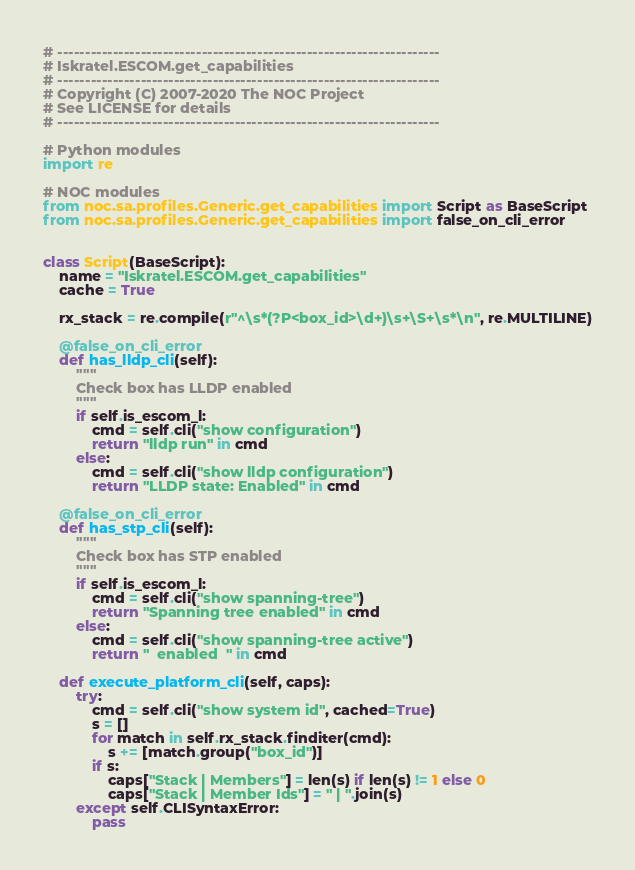<code> <loc_0><loc_0><loc_500><loc_500><_Python_># ---------------------------------------------------------------------
# Iskratel.ESCOM.get_capabilities
# ---------------------------------------------------------------------
# Copyright (C) 2007-2020 The NOC Project
# See LICENSE for details
# ---------------------------------------------------------------------

# Python modules
import re

# NOC modules
from noc.sa.profiles.Generic.get_capabilities import Script as BaseScript
from noc.sa.profiles.Generic.get_capabilities import false_on_cli_error


class Script(BaseScript):
    name = "Iskratel.ESCOM.get_capabilities"
    cache = True

    rx_stack = re.compile(r"^\s*(?P<box_id>\d+)\s+\S+\s*\n", re.MULTILINE)

    @false_on_cli_error
    def has_lldp_cli(self):
        """
        Check box has LLDP enabled
        """
        if self.is_escom_l:
            cmd = self.cli("show configuration")
            return "lldp run" in cmd
        else:
            cmd = self.cli("show lldp configuration")
            return "LLDP state: Enabled" in cmd

    @false_on_cli_error
    def has_stp_cli(self):
        """
        Check box has STP enabled
        """
        if self.is_escom_l:
            cmd = self.cli("show spanning-tree")
            return "Spanning tree enabled" in cmd
        else:
            cmd = self.cli("show spanning-tree active")
            return "  enabled  " in cmd

    def execute_platform_cli(self, caps):
        try:
            cmd = self.cli("show system id", cached=True)
            s = []
            for match in self.rx_stack.finditer(cmd):
                s += [match.group("box_id")]
            if s:
                caps["Stack | Members"] = len(s) if len(s) != 1 else 0
                caps["Stack | Member Ids"] = " | ".join(s)
        except self.CLISyntaxError:
            pass
</code> 